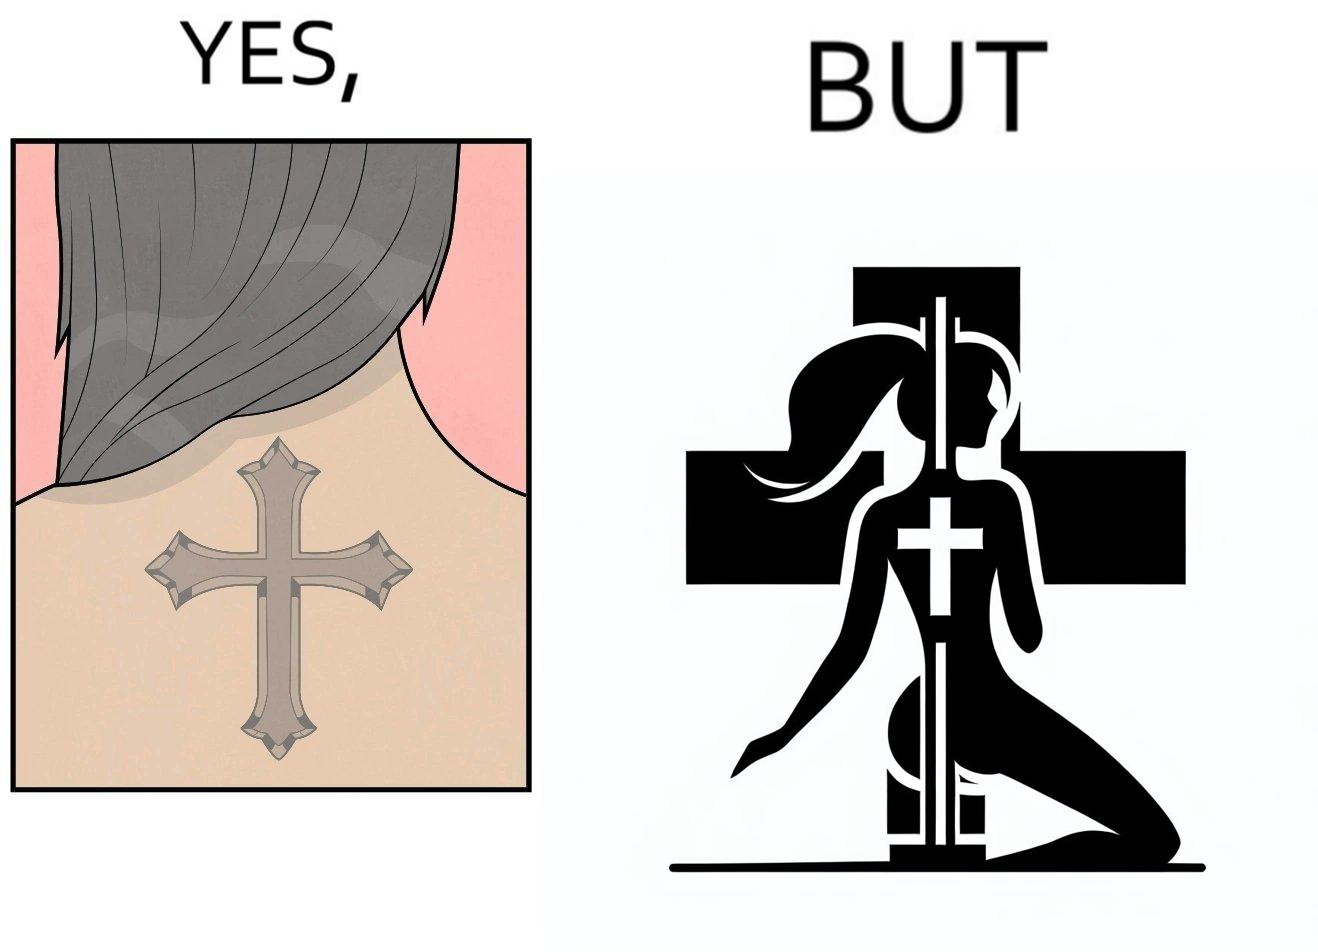What is shown in the left half versus the right half of this image? In the left part of the image: a tatto of holy cross symbol on the back of a girl,maybe she follows christianity as her religion In the right part of the image: a pole dancer performing, having a tatto of holy cross symbol on her back 